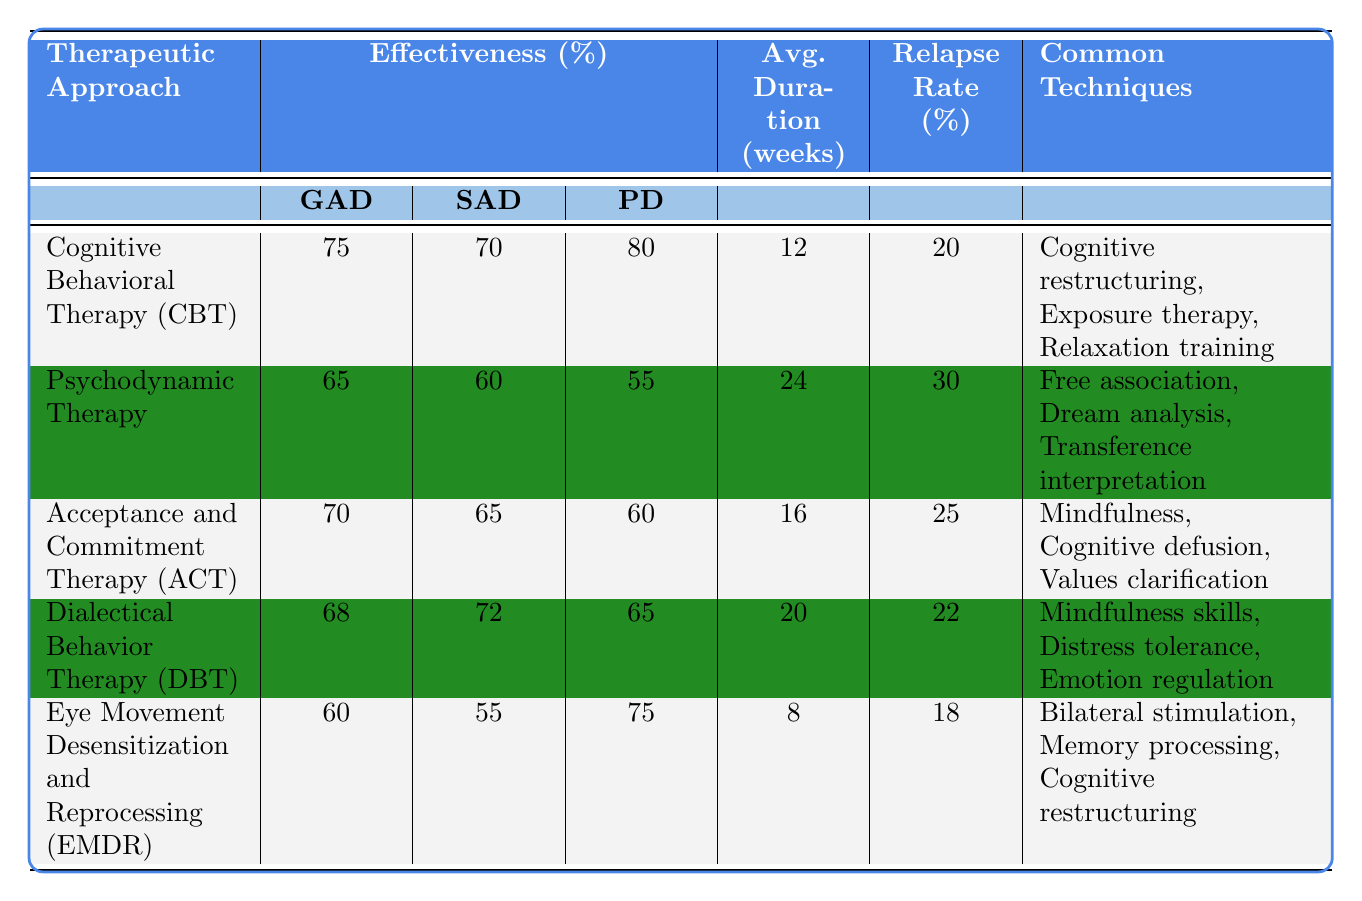What is the effectiveness of Cognitive Behavioral Therapy for Panic Disorder? The effectiveness of Cognitive Behavioral Therapy (CBT) for Panic Disorder is listed in the table under the effectiveness column for Panic Disorder (PD), showing a value of 80%.
Answer: 80% Which therapeutic approach has the highest effectiveness for Generalized Anxiety Disorder? By examining the effectiveness percentages for Generalized Anxiety Disorder (GAD) for each approach, Cognitive Behavioral Therapy has the highest value at 75%.
Answer: Cognitive Behavioral Therapy (CBT) What is the average treatment duration for Acceptance and Commitment Therapy? The average treatment duration for Acceptance and Commitment Therapy (ACT) is specified in the table, shown as 16 weeks.
Answer: 16 weeks What is the relapse rate percentage for Eye Movement Desensitization and Reprocessing? Looking at the data for Eye Movement Desensitization and Reprocessing (EMDR), the relapse rate percentage is provided as 18%.
Answer: 18% What is the difference in effectiveness for Social Anxiety Disorder between Psychodynamic Therapy and Dialectical Behavior Therapy? The effectiveness for Social Anxiety Disorder from the table shows that Psychodynamic Therapy (60%) has a lower effectiveness than Dialectical Behavior Therapy (72%). The difference is calculated as 72% - 60% = 12%.
Answer: 12% Does Acceptance and Commitment Therapy have a lower relapse rate than Psychodynamic Therapy? The relapse rates are 25% for Acceptance and Commitment Therapy, and 30% for Psychodynamic Therapy. Since 25% is less than 30%, the statement is true.
Answer: Yes Which approach has the least effectiveness in treating Social Anxiety Disorder? By reviewing the effectiveness values for Social Anxiety Disorder, Eye Movement Desensitization and Reprocessing has the lowest effectiveness at 55%.
Answer: Eye Movement Desensitization and Reprocessing (EMDR) Calculate the average effectiveness of all therapies for Panic Disorder. Summing the effectiveness values for Panic Disorder: CBT (80) + Psychodynamic (55) + ACT (60) + DBT (65) + EMDR (75) gives a total of 335. There are 5 approaches, so the average is 335/5 = 67%.
Answer: 67% Which therapeutic approach has the shortest average treatment duration? The average treatment durations are: CBT (12 weeks), Psychodynamic Therapy (24 weeks), ACT (16 weeks), DBT (20 weeks), and EMDR (8 weeks). EMDR has the shortest duration of 8 weeks.
Answer: Eye Movement Desensitization and Reprocessing (EMDR) What common technique is shared by both Cognitive Behavioral Therapy and Acceptance and Commitment Therapy? By looking at the common techniques listed for both therapies, "Cognitive restructuring" is found in CBT and also has been used as a technique in EMDR but is not explicitly listed for ACT; however, there is no overlap in common techniques listed, thus the common techniques differ.
Answer: None Which therapy has the highest relapse rate? Upon reviewing the relapse rates, Psychodynamic Therapy has the highest rate at 30%.
Answer: Psychodynamic Therapy 